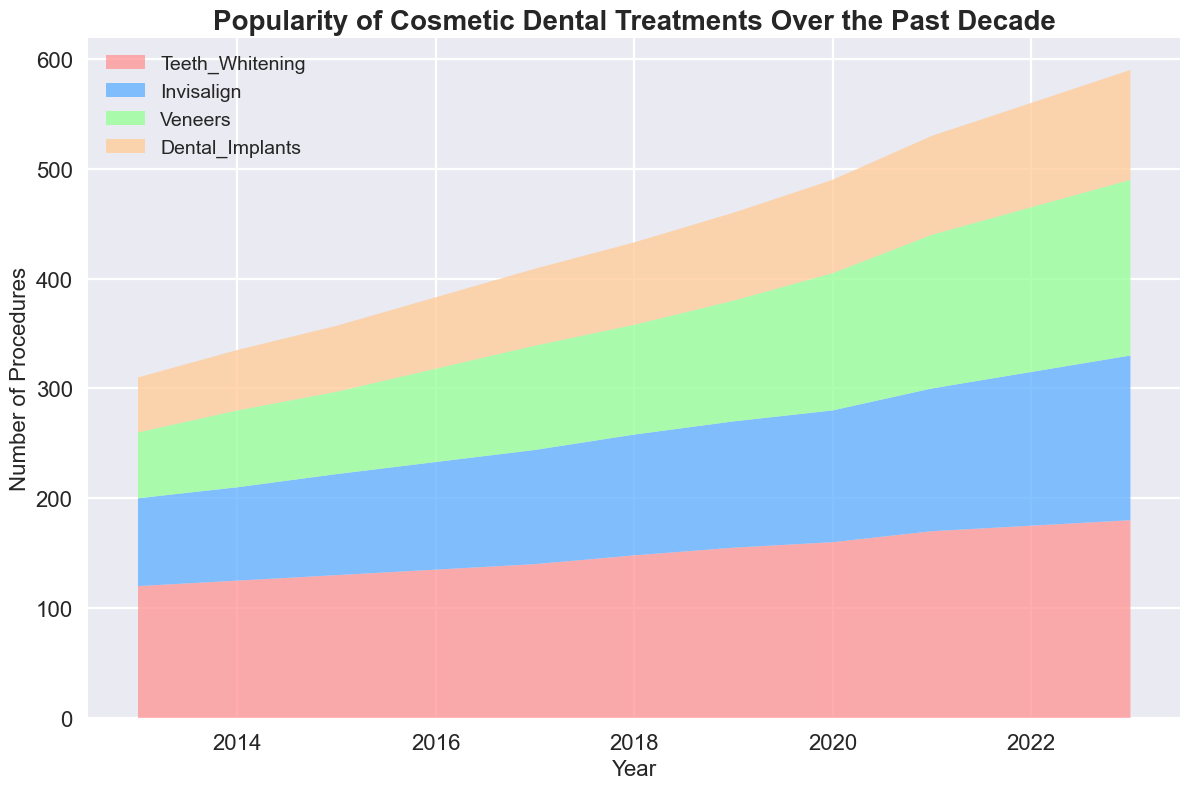Which treatment had the highest number of procedures in 2023? The visual height of the area representing each treatment shows that Teeth Whitening had the highest number of procedures in 2023.
Answer: Teeth Whitening How did the popularity of Dental Implants change between 2013 and 2023? Compare the area height representing Dental Implants at both ends of the chart. It increased from 50 in 2013 to 100 in 2023.
Answer: Increased Which year saw the steepest increase in the popularity of Invisalign? Identify the steepest slope in the area representing Invisalign. The largest increase occurs between 2021 (130) and 2022 (140) with a 10 unit rise, though it's consistent most years.
Answer: 2022 On average, by how many procedures did the popularity of Veneers increase per year from 2013 to 2023? Calculate the difference in numbers between 2013 and 2023 (160 - 60 = 100) and then divide by the number of years (2023 - 2013 = 10). So, 100/10 = 10.
Answer: 10 What is the combined number of procedures for all treatments in 2018? Sum the values of all treatments for 2018: 148 (Teeth Whitening) + 110 (Invisalign) + 100 (Veneers) + 75 (Dental Implants). The total is 433.
Answer: 433 Which treatment experienced the most consistent growth over the decade? Examine the slope consistency for each treatment's area. Teeth Whitening shows a consistent gradual increase every year.
Answer: Teeth Whitening In 2021, how many more procedures were performed for Teeth Whitening than for Veneers? Subtract the value for Veneers from Teeth Whitening in 2021, 170 - 140 = 30.
Answer: 30 What is the difference between the number of Invisalign procedures in 2023 and Dental Implants in 2023? Subtract Dental Implants (100) from Invisalign (150) in 2023. The difference is 150 - 100 = 50.
Answer: 50 